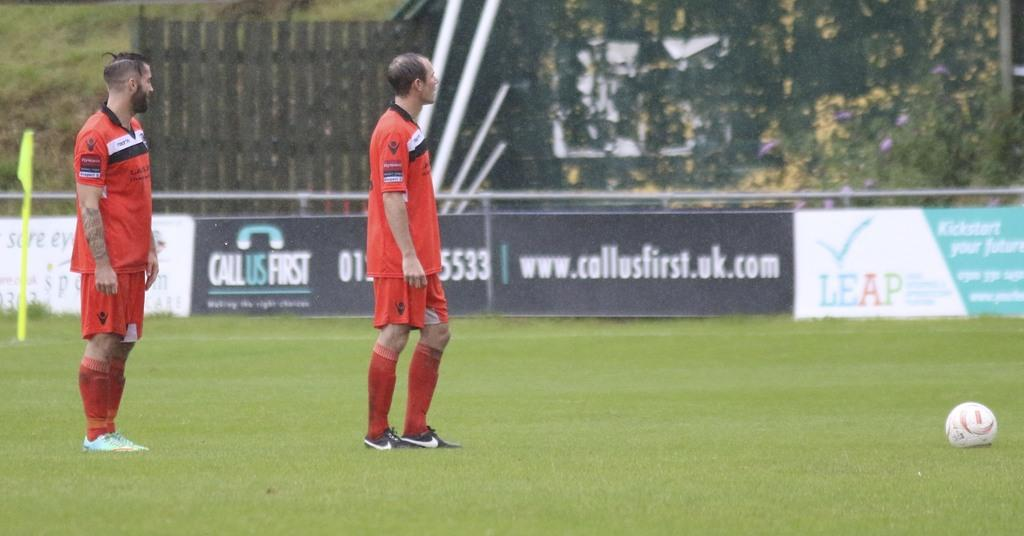<image>
Render a clear and concise summary of the photo. Two men in orange soccer uniforms in front of a sign that says www.collusfirst.uk.com 